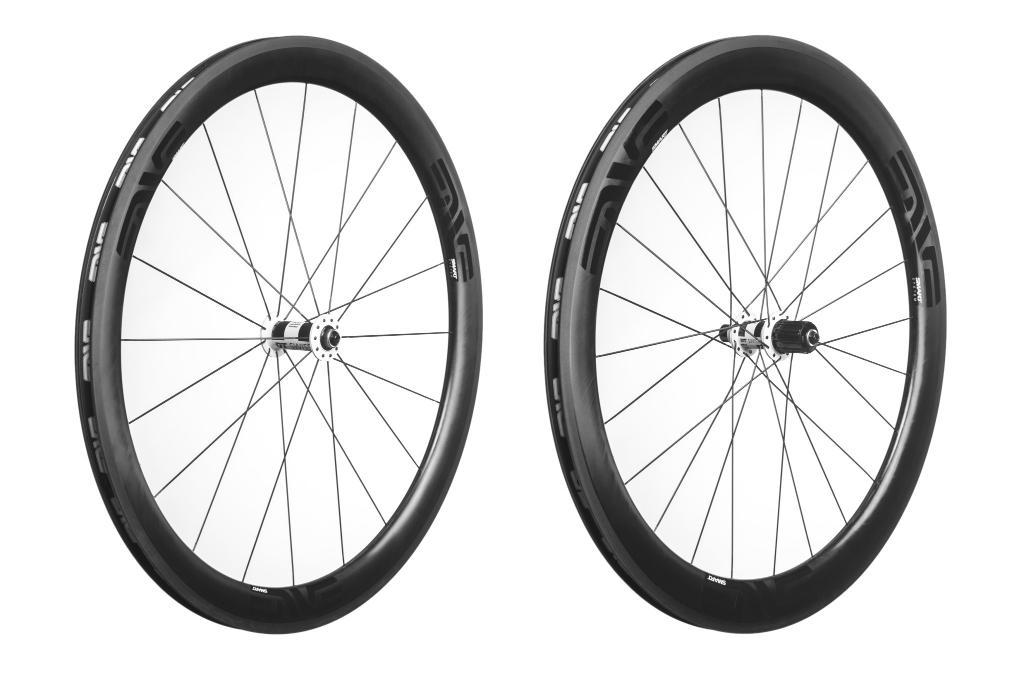What objects are present in the image that have wheels? There are two wheels in the image. What type of trousers are being worn by the person in the image? There is no person present in the image, only two wheels. What type of loaf is being prepared in the image? There is no loaf or any indication of food preparation in the image, only two wheels. 